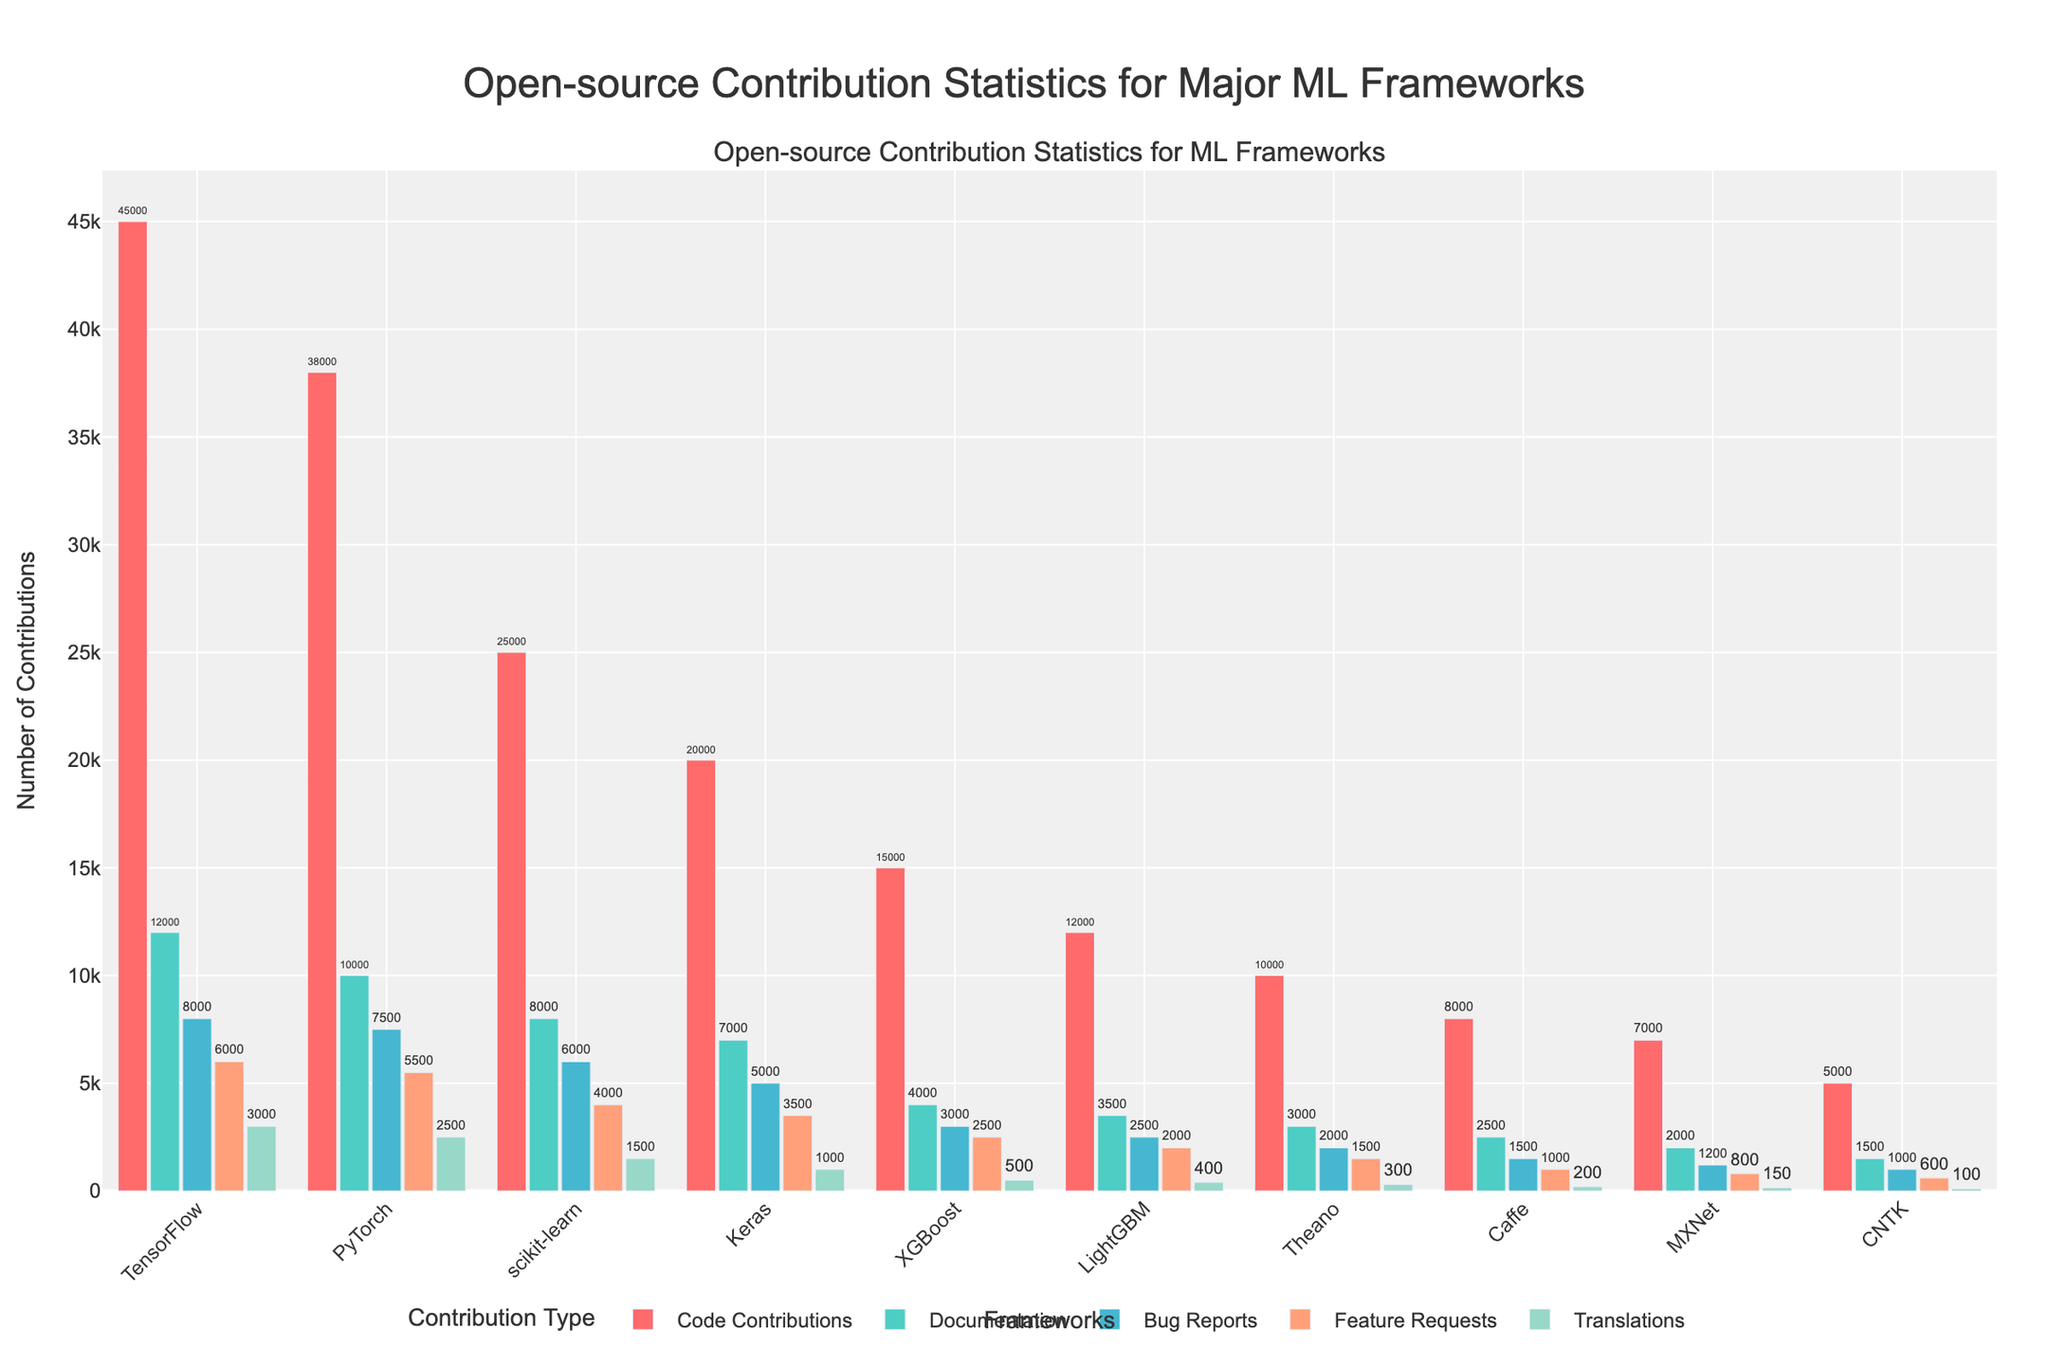What framework has the highest number of code contributions? TensorFlow has the tallest bar in the "Code Contributions" category, indicating the highest number of code contributions.
Answer: TensorFlow Which framework has more documentation contributions, PyTorch or Keras? By comparing the heights of the bars for "Documentation" contributions, PyTorch's bar is taller than Keras's bar.
Answer: PyTorch What is the total number of bug reports received by LightGBM, Theano, and Caffe combined? Add the "Bug Reports" contributions for LightGBM (2500), Theano (2000), and Caffe (1500): \(2500 + 2000 + 1500 = 6000\).
Answer: 6000 Which framework has the lowest number of translations contributions? By looking at the "Translations" contributions, CNTK has the shortest bar, indicating the lowest number (100).
Answer: CNTK How many more code contributions does TensorFlow have compared to scikit-learn? TensorFlow has 45000 code contributions and scikit-learn has 25000. Subtract scikit-learn's contributions from TensorFlow's: \(45000 - 25000 = 20000\).
Answer: 20000 What is the average number of feature requests for all frameworks? Adding the "Feature Requests" for each framework gives: \(6000 + 5500 + 4000 + 3500 + 2500 + 2000 + 1500 + 1000 + 800 + 600 = 27400\). There are 10 frameworks: \(27400 / 10 = 2740\).
Answer: 2740 Which framework has more total contributions across all types, Keras or XGBoost? Sum the contributions for Keras: \(20000 + 7000 + 5000 + 3500 + 1000 = 36500\). Sum the contributions for XGBoost: \(15000 + 4000 + 3000 + 2500 + 500 = 25000\). Keras's total is higher.
Answer: Keras Which framework has fewer bug reports, MXNet or CNTK? By comparing the "Bug Reports" contributions, MXNet has 1200 and CNTK has 1000, so CNTK has fewer.
Answer: CNTK Which contribution type has ten contributions greater than 6000 for any framework? By checking each contribution type and framework, only "Code Contributions" have ten values that are greater than 6000.
Answer: Code Contributions 